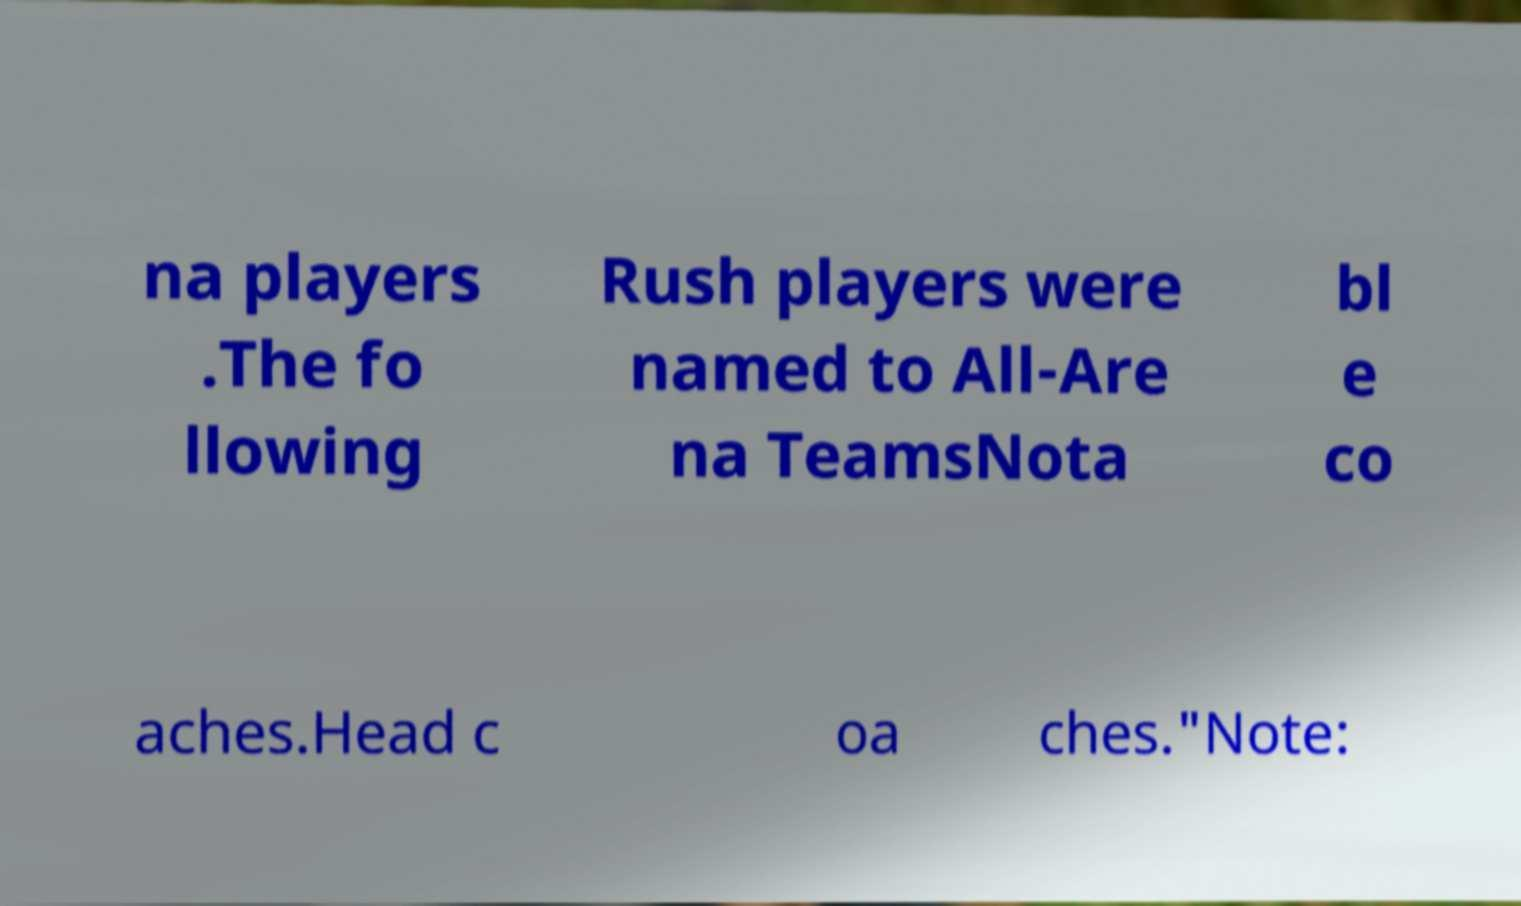Please read and relay the text visible in this image. What does it say? na players .The fo llowing Rush players were named to All-Are na TeamsNota bl e co aches.Head c oa ches."Note: 